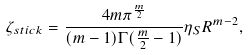Convert formula to latex. <formula><loc_0><loc_0><loc_500><loc_500>\zeta _ { s t i c k } = \frac { 4 m \pi ^ { \frac { m } { 2 } } } { ( m - 1 ) \Gamma ( \frac { m } { 2 } - 1 ) } \eta _ { S } R ^ { m - 2 } ,</formula> 